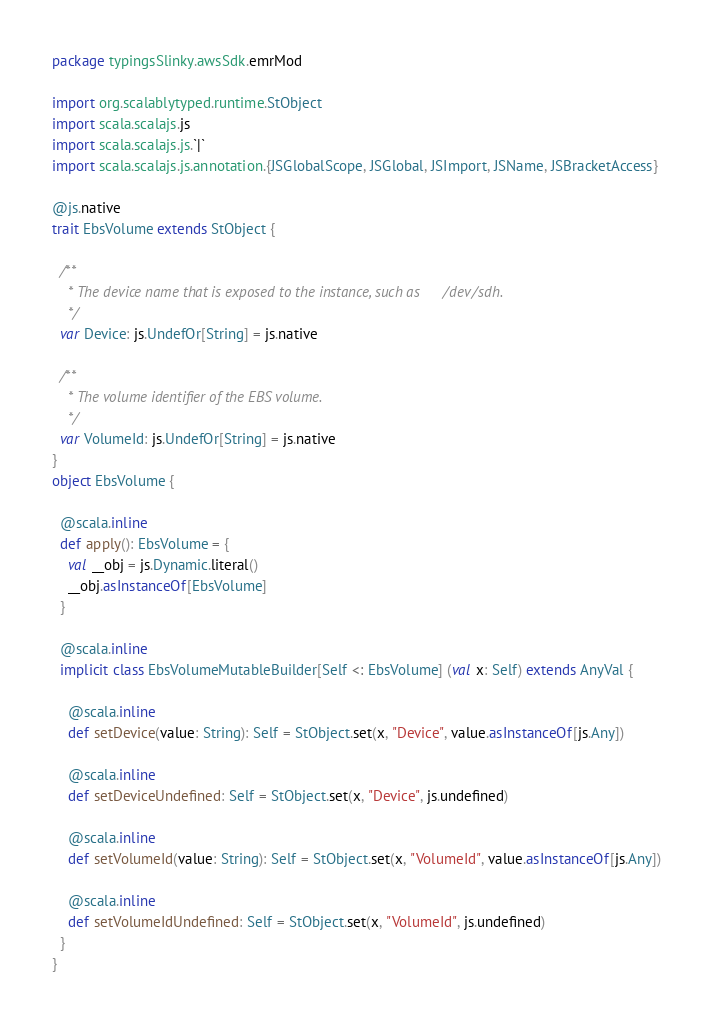Convert code to text. <code><loc_0><loc_0><loc_500><loc_500><_Scala_>package typingsSlinky.awsSdk.emrMod

import org.scalablytyped.runtime.StObject
import scala.scalajs.js
import scala.scalajs.js.`|`
import scala.scalajs.js.annotation.{JSGlobalScope, JSGlobal, JSImport, JSName, JSBracketAccess}

@js.native
trait EbsVolume extends StObject {
  
  /**
    * The device name that is exposed to the instance, such as /dev/sdh.
    */
  var Device: js.UndefOr[String] = js.native
  
  /**
    * The volume identifier of the EBS volume.
    */
  var VolumeId: js.UndefOr[String] = js.native
}
object EbsVolume {
  
  @scala.inline
  def apply(): EbsVolume = {
    val __obj = js.Dynamic.literal()
    __obj.asInstanceOf[EbsVolume]
  }
  
  @scala.inline
  implicit class EbsVolumeMutableBuilder[Self <: EbsVolume] (val x: Self) extends AnyVal {
    
    @scala.inline
    def setDevice(value: String): Self = StObject.set(x, "Device", value.asInstanceOf[js.Any])
    
    @scala.inline
    def setDeviceUndefined: Self = StObject.set(x, "Device", js.undefined)
    
    @scala.inline
    def setVolumeId(value: String): Self = StObject.set(x, "VolumeId", value.asInstanceOf[js.Any])
    
    @scala.inline
    def setVolumeIdUndefined: Self = StObject.set(x, "VolumeId", js.undefined)
  }
}
</code> 